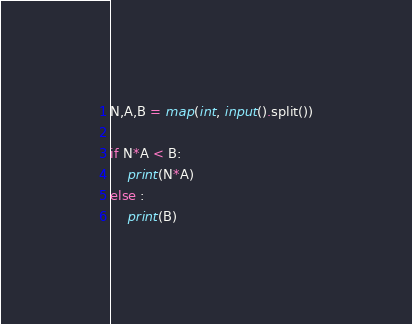Convert code to text. <code><loc_0><loc_0><loc_500><loc_500><_Python_>
N,A,B = map(int, input().split())

if N*A < B:
    print(N*A)
else :
    print(B)</code> 